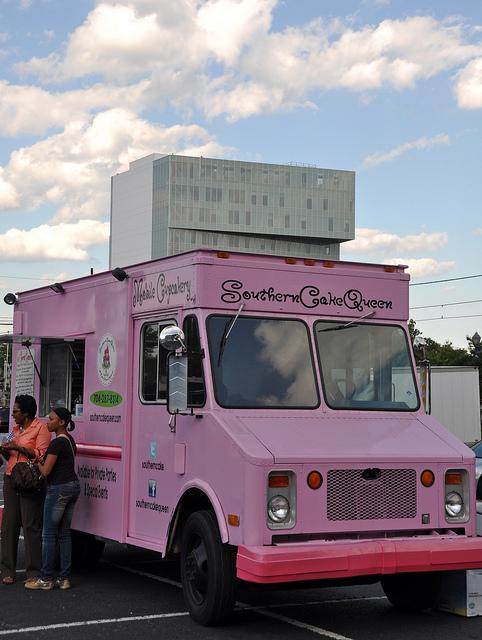What number is on the front of this train?
Be succinct. Not train. Is this a truck for transporting good?
Give a very brief answer. Yes. Is this a bus?
Answer briefly. No. What is being sold from the truck?
Keep it brief. Cake. What is the name of the lunch truck?
Be succinct. Southern cake queen. How many people are standing around the truck?
Give a very brief answer. 2. Does the lunch truck sell chicken quesadillas?
Quick response, please. No. What color is the truck?
Answer briefly. Pink. 